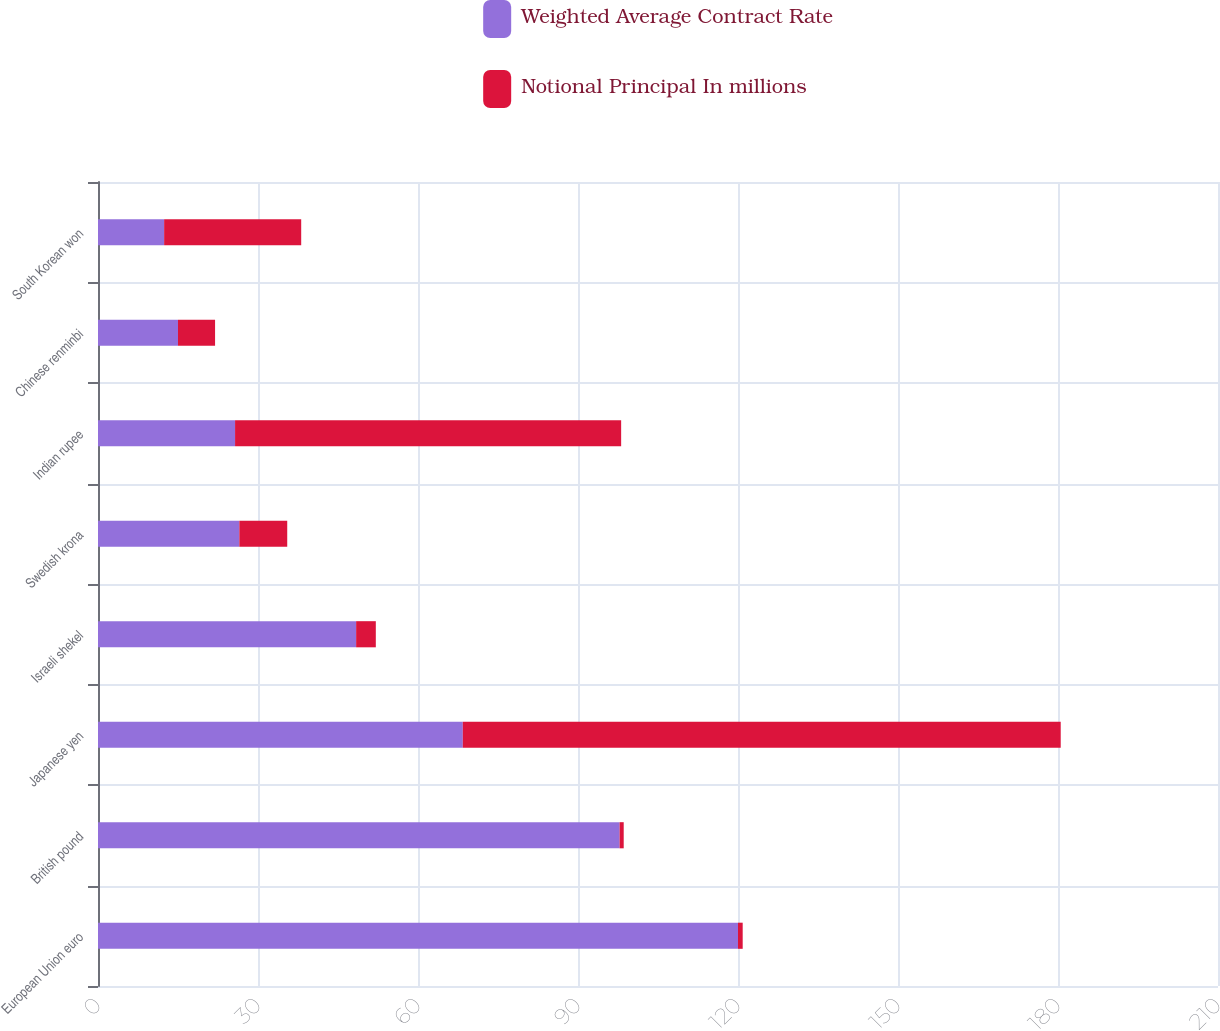Convert chart to OTSL. <chart><loc_0><loc_0><loc_500><loc_500><stacked_bar_chart><ecel><fcel>European Union euro<fcel>British pound<fcel>Japanese yen<fcel>Israeli shekel<fcel>Swedish krona<fcel>Indian rupee<fcel>Chinese renminbi<fcel>South Korean won<nl><fcel>Weighted Average Contract Rate<fcel>120<fcel>97.8<fcel>68.4<fcel>48.4<fcel>26.5<fcel>25.7<fcel>15<fcel>12.4<nl><fcel>Notional Principal In millions<fcel>0.88<fcel>0.77<fcel>112.11<fcel>3.69<fcel>8.98<fcel>72.39<fcel>6.95<fcel>25.7<nl></chart> 